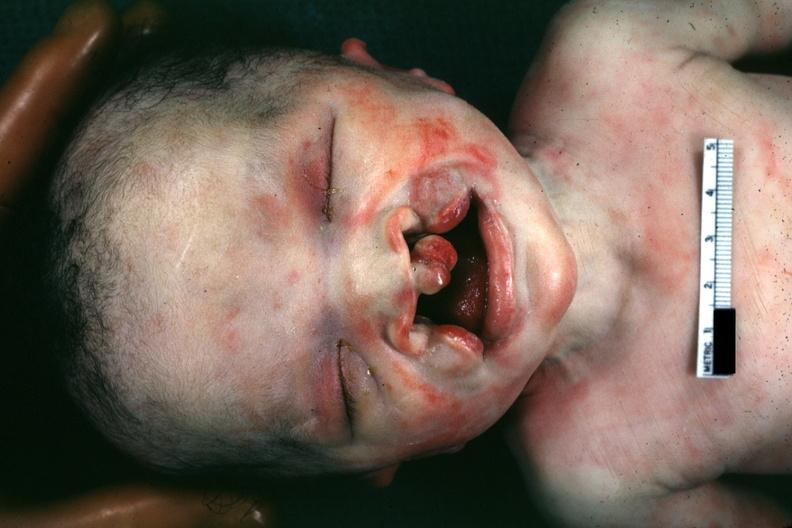what is present?
Answer the question using a single word or phrase. Face 